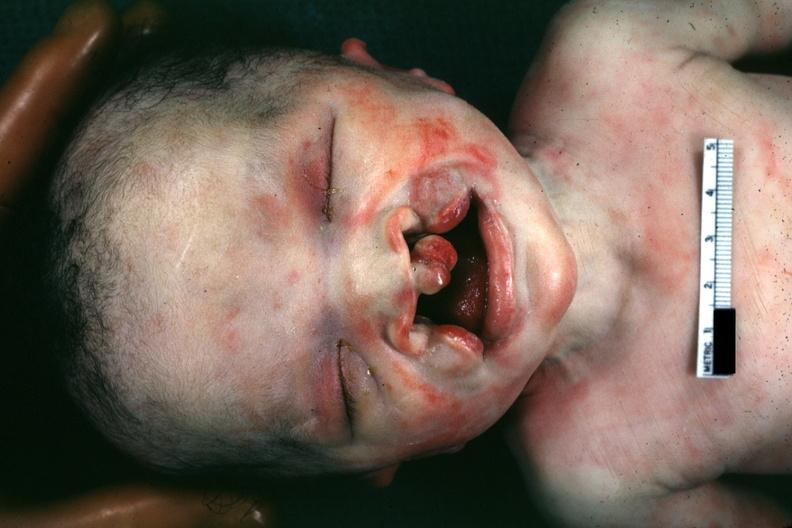what is present?
Answer the question using a single word or phrase. Face 